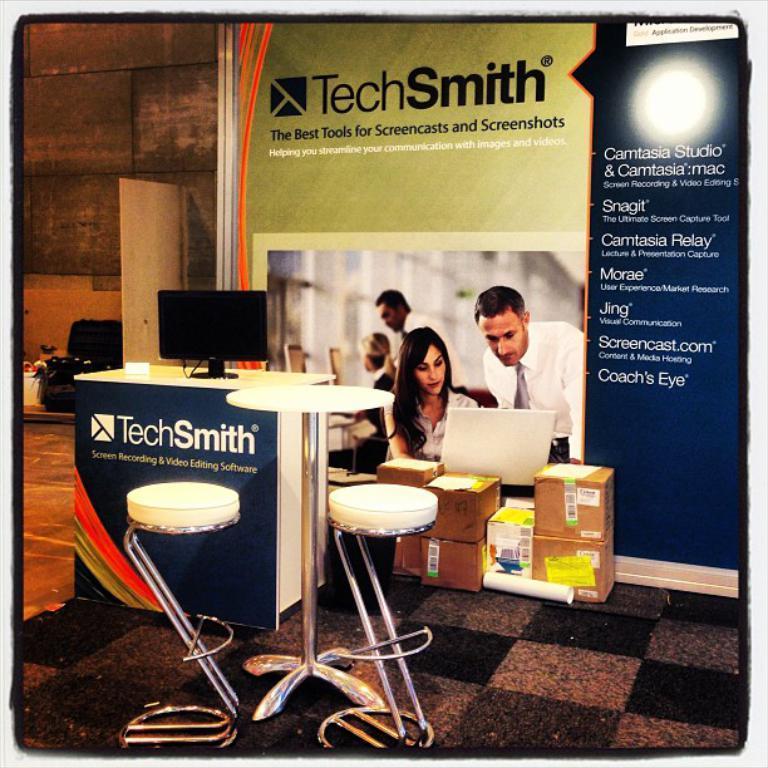Describe this image in one or two sentences. In this image in the center there is a stool which is white in colour and there is a table with sub text written on it and on the table there is a monitor and there is a banner with some text on it. In front of the banner there are carton boxes. On the left side there is an object which is black in colour and there is a white colour sheet. 